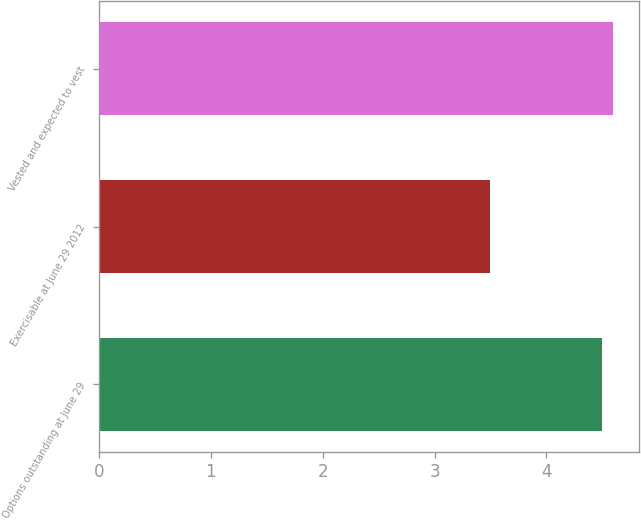Convert chart to OTSL. <chart><loc_0><loc_0><loc_500><loc_500><bar_chart><fcel>Options outstanding at June 29<fcel>Exercisable at June 29 2012<fcel>Vested and expected to vest<nl><fcel>4.5<fcel>3.5<fcel>4.6<nl></chart> 